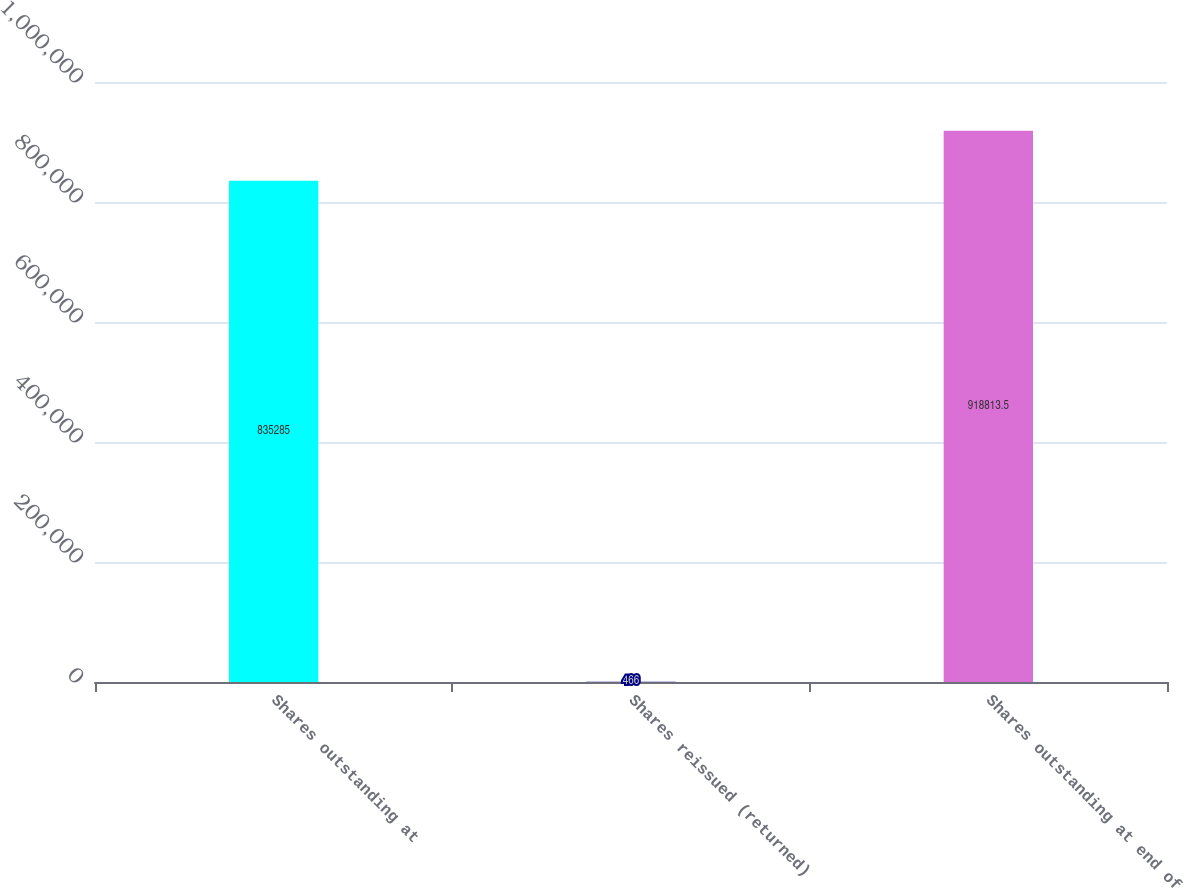Convert chart. <chart><loc_0><loc_0><loc_500><loc_500><bar_chart><fcel>Shares outstanding at<fcel>Shares reissued (returned)<fcel>Shares outstanding at end of<nl><fcel>835285<fcel>466<fcel>918814<nl></chart> 